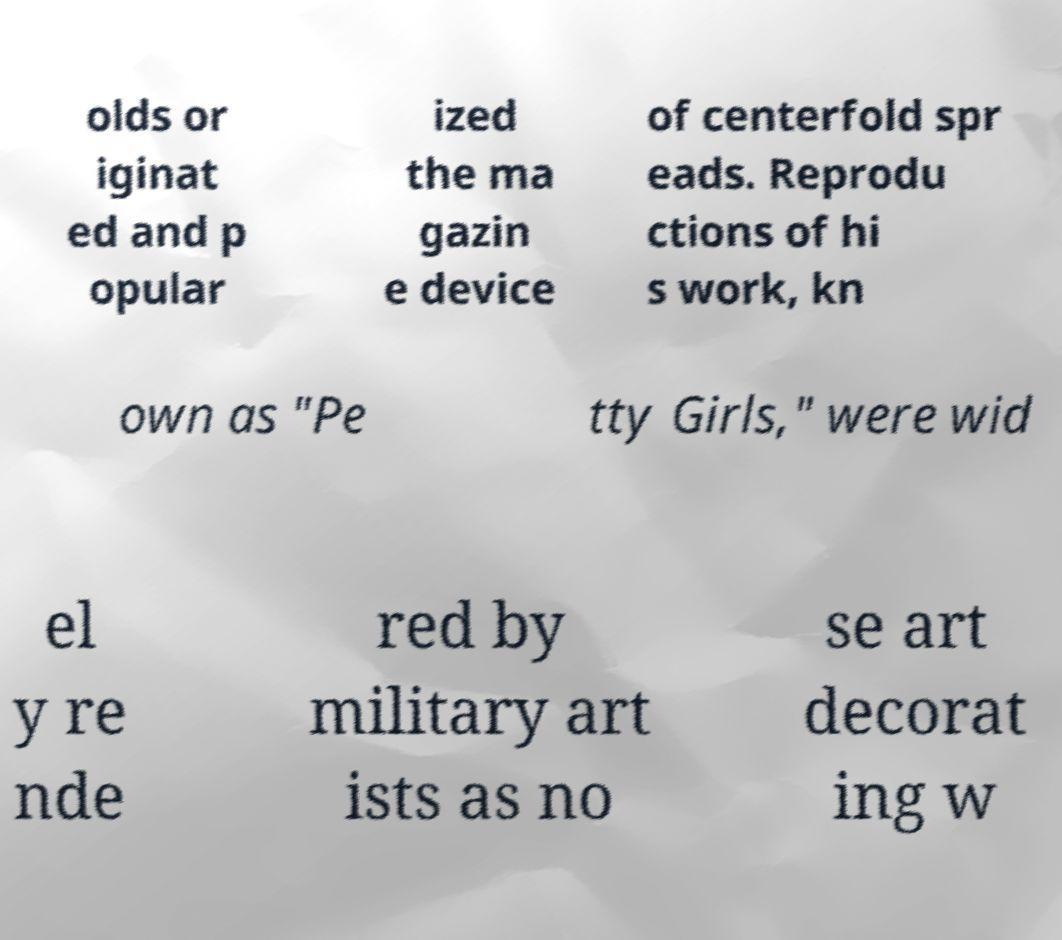Could you assist in decoding the text presented in this image and type it out clearly? olds or iginat ed and p opular ized the ma gazin e device of centerfold spr eads. Reprodu ctions of hi s work, kn own as "Pe tty Girls," were wid el y re nde red by military art ists as no se art decorat ing w 